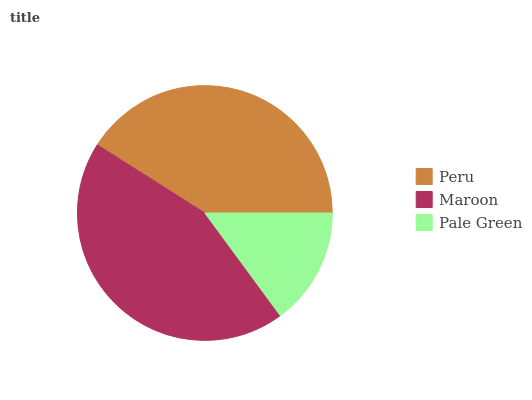Is Pale Green the minimum?
Answer yes or no. Yes. Is Maroon the maximum?
Answer yes or no. Yes. Is Maroon the minimum?
Answer yes or no. No. Is Pale Green the maximum?
Answer yes or no. No. Is Maroon greater than Pale Green?
Answer yes or no. Yes. Is Pale Green less than Maroon?
Answer yes or no. Yes. Is Pale Green greater than Maroon?
Answer yes or no. No. Is Maroon less than Pale Green?
Answer yes or no. No. Is Peru the high median?
Answer yes or no. Yes. Is Peru the low median?
Answer yes or no. Yes. Is Maroon the high median?
Answer yes or no. No. Is Pale Green the low median?
Answer yes or no. No. 